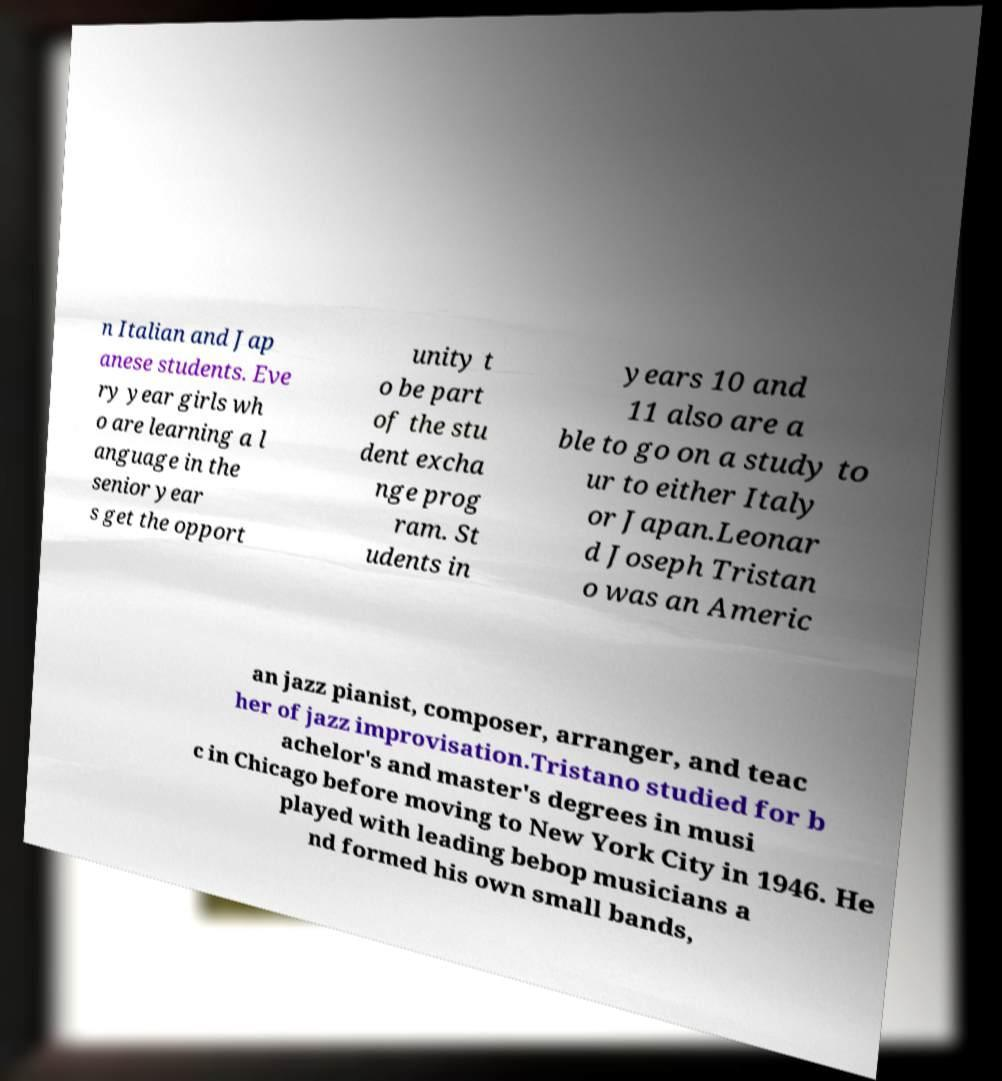Can you read and provide the text displayed in the image?This photo seems to have some interesting text. Can you extract and type it out for me? n Italian and Jap anese students. Eve ry year girls wh o are learning a l anguage in the senior year s get the opport unity t o be part of the stu dent excha nge prog ram. St udents in years 10 and 11 also are a ble to go on a study to ur to either Italy or Japan.Leonar d Joseph Tristan o was an Americ an jazz pianist, composer, arranger, and teac her of jazz improvisation.Tristano studied for b achelor's and master's degrees in musi c in Chicago before moving to New York City in 1946. He played with leading bebop musicians a nd formed his own small bands, 